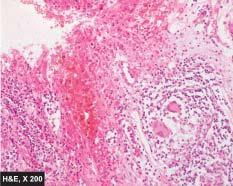re the histological features present: transmural chronic inflammatory cell infiltration, deep fissures into the bowel wall, submucosal widening due to oedema, some prominent lymphoid follicles and a few non-caseating epithelioid cell granulomas in the bowel wall?
Answer the question using a single word or phrase. Yes 